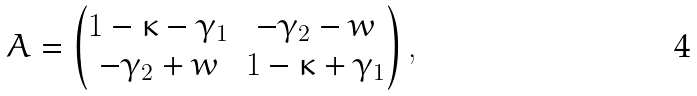Convert formula to latex. <formula><loc_0><loc_0><loc_500><loc_500>A = \begin{pmatrix} 1 - \kappa - \gamma _ { 1 } & - \gamma _ { 2 } - w \\ - \gamma _ { 2 } + w & 1 - \kappa + \gamma _ { 1 } \end{pmatrix} ,</formula> 